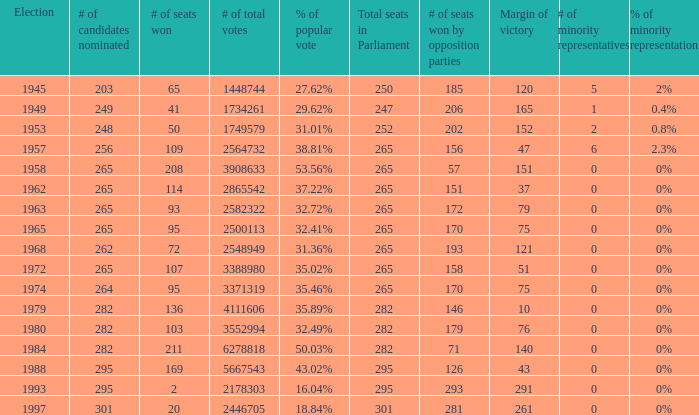Could you parse the entire table as a dict? {'header': ['Election', '# of candidates nominated', '# of seats won', '# of total votes', '% of popular vote', 'Total seats in Parliament', '# of seats won by opposition parties', 'Margin of victory', '# of minority representatives', '% of minority representation'], 'rows': [['1945', '203', '65', '1448744', '27.62%', '250', '185', '120', '5', '2%'], ['1949', '249', '41', '1734261', '29.62%', '247', '206', '165', '1', '0.4%'], ['1953', '248', '50', '1749579', '31.01%', '252', '202', '152', '2', '0.8%'], ['1957', '256', '109', '2564732', '38.81%', '265', '156', '47', '6', '2.3%'], ['1958', '265', '208', '3908633', '53.56%', '265', '57', '151', '0', '0%'], ['1962', '265', '114', '2865542', '37.22%', '265', '151', '37', '0', '0%'], ['1963', '265', '93', '2582322', '32.72%', '265', '172', '79', '0', '0%'], ['1965', '265', '95', '2500113', '32.41%', '265', '170', '75', '0', '0%'], ['1968', '262', '72', '2548949', '31.36%', '265', '193', '121', '0', '0%'], ['1972', '265', '107', '3388980', '35.02%', '265', '158', '51', '0', '0%'], ['1974', '264', '95', '3371319', '35.46%', '265', '170', '75', '0', '0%'], ['1979', '282', '136', '4111606', '35.89%', '282', '146', '10', '0', '0%'], ['1980', '282', '103', '3552994', '32.49%', '282', '179', '76', '0', '0%'], ['1984', '282', '211', '6278818', '50.03%', '282', '71', '140', '0', '0%'], ['1988', '295', '169', '5667543', '43.02%', '295', '126', '43', '0', '0%'], ['1993', '295', '2', '2178303', '16.04%', '295', '293', '291', '0', '0%'], ['1997', '301', '20', '2446705', '18.84%', '301', '281', '261', '0', '0%']]} How many times was the # of total votes 2582322? 1.0. 